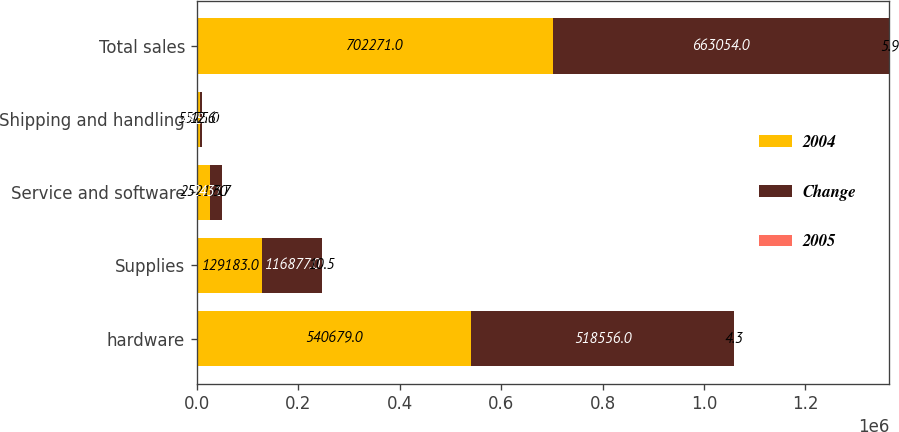Convert chart to OTSL. <chart><loc_0><loc_0><loc_500><loc_500><stacked_bar_chart><ecel><fcel>hardware<fcel>Supplies<fcel>Service and software<fcel>Shipping and handling<fcel>Total sales<nl><fcel>2004<fcel>540679<fcel>129183<fcel>25217<fcel>5575<fcel>702271<nl><fcel>Change<fcel>518556<fcel>116877<fcel>24310<fcel>4950<fcel>663054<nl><fcel>2005<fcel>4.3<fcel>10.5<fcel>3.7<fcel>12.6<fcel>5.9<nl></chart> 